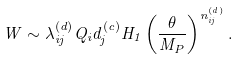<formula> <loc_0><loc_0><loc_500><loc_500>W \sim \lambda _ { i j } ^ { ( d ) } Q _ { i } d _ { j } ^ { ( c ) } H _ { 1 } \left ( \frac { \theta } { M _ { P } } \right ) ^ { n _ { i j } ^ { ( d ) } } .</formula> 